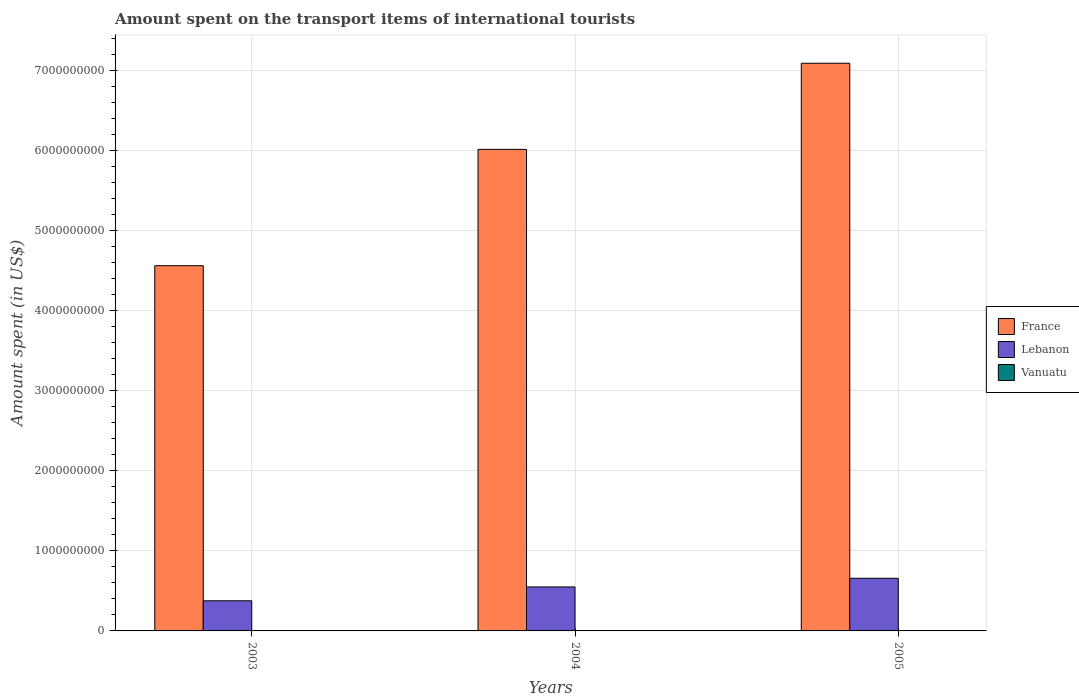How many groups of bars are there?
Ensure brevity in your answer.  3. Are the number of bars per tick equal to the number of legend labels?
Offer a very short reply. Yes. What is the label of the 2nd group of bars from the left?
Provide a succinct answer. 2004. In how many cases, is the number of bars for a given year not equal to the number of legend labels?
Provide a short and direct response. 0. What is the amount spent on the transport items of international tourists in Lebanon in 2004?
Give a very brief answer. 5.49e+08. Across all years, what is the maximum amount spent on the transport items of international tourists in France?
Provide a succinct answer. 7.09e+09. In which year was the amount spent on the transport items of international tourists in Vanuatu maximum?
Offer a very short reply. 2003. In which year was the amount spent on the transport items of international tourists in Vanuatu minimum?
Keep it short and to the point. 2003. What is the total amount spent on the transport items of international tourists in France in the graph?
Ensure brevity in your answer.  1.77e+1. What is the difference between the amount spent on the transport items of international tourists in Lebanon in 2003 and that in 2005?
Offer a terse response. -2.81e+08. What is the difference between the amount spent on the transport items of international tourists in Vanuatu in 2003 and the amount spent on the transport items of international tourists in Lebanon in 2005?
Provide a short and direct response. -6.55e+08. What is the average amount spent on the transport items of international tourists in Lebanon per year?
Provide a short and direct response. 5.27e+08. In the year 2003, what is the difference between the amount spent on the transport items of international tourists in Vanuatu and amount spent on the transport items of international tourists in France?
Your response must be concise. -4.56e+09. What is the ratio of the amount spent on the transport items of international tourists in Vanuatu in 2004 to that in 2005?
Offer a very short reply. 1. What is the difference between the highest and the second highest amount spent on the transport items of international tourists in France?
Your answer should be compact. 1.08e+09. In how many years, is the amount spent on the transport items of international tourists in Vanuatu greater than the average amount spent on the transport items of international tourists in Vanuatu taken over all years?
Make the answer very short. 0. What does the 1st bar from the right in 2004 represents?
Provide a succinct answer. Vanuatu. Are all the bars in the graph horizontal?
Your answer should be very brief. No. How many years are there in the graph?
Make the answer very short. 3. Are the values on the major ticks of Y-axis written in scientific E-notation?
Provide a short and direct response. No. Does the graph contain any zero values?
Give a very brief answer. No. Does the graph contain grids?
Keep it short and to the point. Yes. How many legend labels are there?
Ensure brevity in your answer.  3. What is the title of the graph?
Your answer should be very brief. Amount spent on the transport items of international tourists. Does "Albania" appear as one of the legend labels in the graph?
Offer a terse response. No. What is the label or title of the X-axis?
Offer a very short reply. Years. What is the label or title of the Y-axis?
Provide a succinct answer. Amount spent (in US$). What is the Amount spent (in US$) of France in 2003?
Your answer should be compact. 4.56e+09. What is the Amount spent (in US$) in Lebanon in 2003?
Provide a succinct answer. 3.76e+08. What is the Amount spent (in US$) in Vanuatu in 2003?
Make the answer very short. 2.00e+06. What is the Amount spent (in US$) of France in 2004?
Your answer should be very brief. 6.01e+09. What is the Amount spent (in US$) of Lebanon in 2004?
Your answer should be very brief. 5.49e+08. What is the Amount spent (in US$) of France in 2005?
Ensure brevity in your answer.  7.09e+09. What is the Amount spent (in US$) of Lebanon in 2005?
Your answer should be compact. 6.57e+08. What is the Amount spent (in US$) in Vanuatu in 2005?
Make the answer very short. 2.00e+06. Across all years, what is the maximum Amount spent (in US$) of France?
Your answer should be compact. 7.09e+09. Across all years, what is the maximum Amount spent (in US$) of Lebanon?
Your response must be concise. 6.57e+08. Across all years, what is the maximum Amount spent (in US$) of Vanuatu?
Ensure brevity in your answer.  2.00e+06. Across all years, what is the minimum Amount spent (in US$) of France?
Provide a succinct answer. 4.56e+09. Across all years, what is the minimum Amount spent (in US$) of Lebanon?
Your answer should be compact. 3.76e+08. What is the total Amount spent (in US$) of France in the graph?
Make the answer very short. 1.77e+1. What is the total Amount spent (in US$) in Lebanon in the graph?
Keep it short and to the point. 1.58e+09. What is the difference between the Amount spent (in US$) in France in 2003 and that in 2004?
Your answer should be compact. -1.45e+09. What is the difference between the Amount spent (in US$) of Lebanon in 2003 and that in 2004?
Your answer should be very brief. -1.73e+08. What is the difference between the Amount spent (in US$) in France in 2003 and that in 2005?
Provide a short and direct response. -2.53e+09. What is the difference between the Amount spent (in US$) of Lebanon in 2003 and that in 2005?
Provide a succinct answer. -2.81e+08. What is the difference between the Amount spent (in US$) of France in 2004 and that in 2005?
Provide a short and direct response. -1.08e+09. What is the difference between the Amount spent (in US$) of Lebanon in 2004 and that in 2005?
Make the answer very short. -1.08e+08. What is the difference between the Amount spent (in US$) in Vanuatu in 2004 and that in 2005?
Keep it short and to the point. 0. What is the difference between the Amount spent (in US$) of France in 2003 and the Amount spent (in US$) of Lebanon in 2004?
Keep it short and to the point. 4.01e+09. What is the difference between the Amount spent (in US$) in France in 2003 and the Amount spent (in US$) in Vanuatu in 2004?
Make the answer very short. 4.56e+09. What is the difference between the Amount spent (in US$) in Lebanon in 2003 and the Amount spent (in US$) in Vanuatu in 2004?
Keep it short and to the point. 3.74e+08. What is the difference between the Amount spent (in US$) of France in 2003 and the Amount spent (in US$) of Lebanon in 2005?
Make the answer very short. 3.90e+09. What is the difference between the Amount spent (in US$) of France in 2003 and the Amount spent (in US$) of Vanuatu in 2005?
Offer a very short reply. 4.56e+09. What is the difference between the Amount spent (in US$) in Lebanon in 2003 and the Amount spent (in US$) in Vanuatu in 2005?
Ensure brevity in your answer.  3.74e+08. What is the difference between the Amount spent (in US$) in France in 2004 and the Amount spent (in US$) in Lebanon in 2005?
Your answer should be compact. 5.35e+09. What is the difference between the Amount spent (in US$) of France in 2004 and the Amount spent (in US$) of Vanuatu in 2005?
Offer a very short reply. 6.01e+09. What is the difference between the Amount spent (in US$) in Lebanon in 2004 and the Amount spent (in US$) in Vanuatu in 2005?
Make the answer very short. 5.47e+08. What is the average Amount spent (in US$) in France per year?
Your answer should be very brief. 5.89e+09. What is the average Amount spent (in US$) of Lebanon per year?
Ensure brevity in your answer.  5.27e+08. What is the average Amount spent (in US$) of Vanuatu per year?
Provide a succinct answer. 2.00e+06. In the year 2003, what is the difference between the Amount spent (in US$) of France and Amount spent (in US$) of Lebanon?
Provide a short and direct response. 4.18e+09. In the year 2003, what is the difference between the Amount spent (in US$) of France and Amount spent (in US$) of Vanuatu?
Offer a terse response. 4.56e+09. In the year 2003, what is the difference between the Amount spent (in US$) in Lebanon and Amount spent (in US$) in Vanuatu?
Give a very brief answer. 3.74e+08. In the year 2004, what is the difference between the Amount spent (in US$) of France and Amount spent (in US$) of Lebanon?
Offer a very short reply. 5.46e+09. In the year 2004, what is the difference between the Amount spent (in US$) in France and Amount spent (in US$) in Vanuatu?
Offer a very short reply. 6.01e+09. In the year 2004, what is the difference between the Amount spent (in US$) in Lebanon and Amount spent (in US$) in Vanuatu?
Offer a very short reply. 5.47e+08. In the year 2005, what is the difference between the Amount spent (in US$) of France and Amount spent (in US$) of Lebanon?
Keep it short and to the point. 6.43e+09. In the year 2005, what is the difference between the Amount spent (in US$) of France and Amount spent (in US$) of Vanuatu?
Your response must be concise. 7.08e+09. In the year 2005, what is the difference between the Amount spent (in US$) of Lebanon and Amount spent (in US$) of Vanuatu?
Your answer should be very brief. 6.55e+08. What is the ratio of the Amount spent (in US$) of France in 2003 to that in 2004?
Your answer should be very brief. 0.76. What is the ratio of the Amount spent (in US$) of Lebanon in 2003 to that in 2004?
Ensure brevity in your answer.  0.68. What is the ratio of the Amount spent (in US$) of France in 2003 to that in 2005?
Offer a terse response. 0.64. What is the ratio of the Amount spent (in US$) in Lebanon in 2003 to that in 2005?
Make the answer very short. 0.57. What is the ratio of the Amount spent (in US$) in Vanuatu in 2003 to that in 2005?
Ensure brevity in your answer.  1. What is the ratio of the Amount spent (in US$) of France in 2004 to that in 2005?
Your answer should be very brief. 0.85. What is the ratio of the Amount spent (in US$) in Lebanon in 2004 to that in 2005?
Offer a terse response. 0.84. What is the ratio of the Amount spent (in US$) of Vanuatu in 2004 to that in 2005?
Your answer should be very brief. 1. What is the difference between the highest and the second highest Amount spent (in US$) of France?
Offer a very short reply. 1.08e+09. What is the difference between the highest and the second highest Amount spent (in US$) in Lebanon?
Make the answer very short. 1.08e+08. What is the difference between the highest and the lowest Amount spent (in US$) in France?
Provide a short and direct response. 2.53e+09. What is the difference between the highest and the lowest Amount spent (in US$) in Lebanon?
Ensure brevity in your answer.  2.81e+08. What is the difference between the highest and the lowest Amount spent (in US$) in Vanuatu?
Keep it short and to the point. 0. 